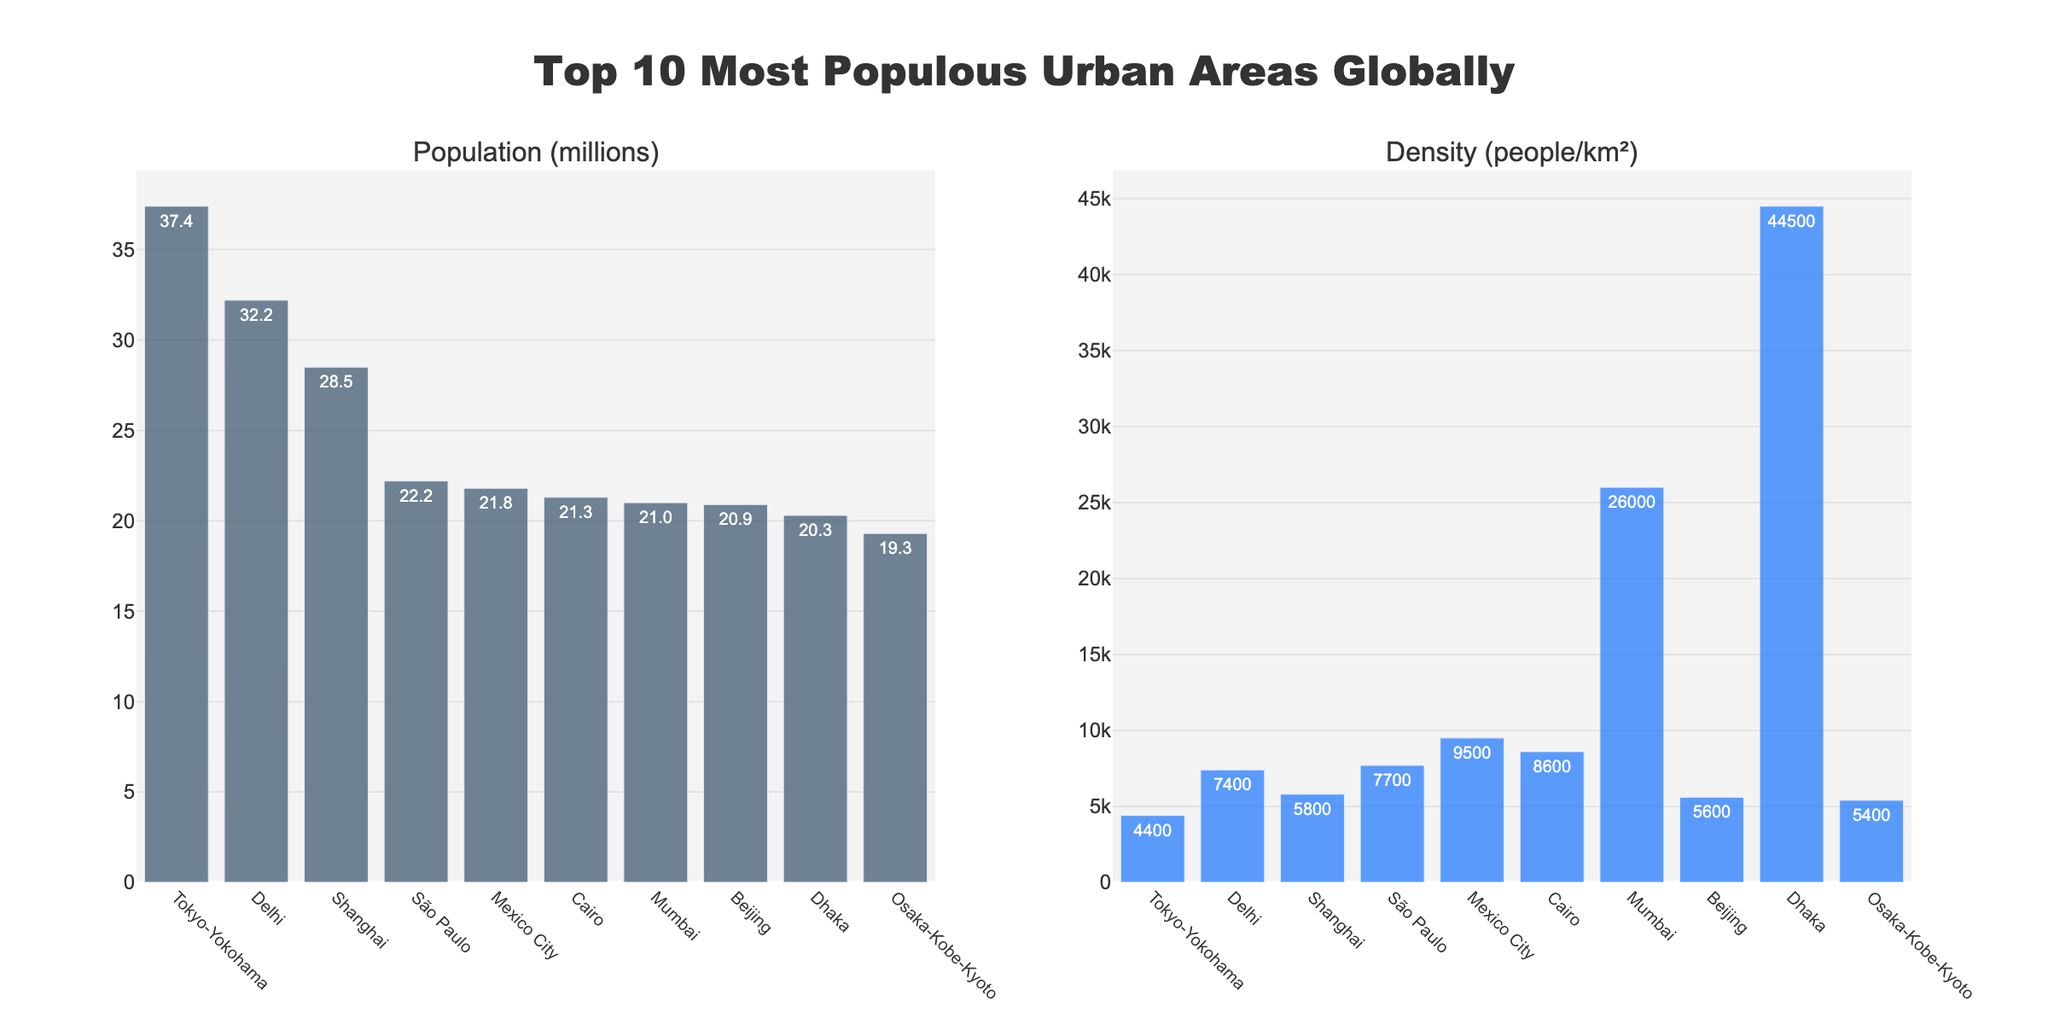Which urban area has the highest population? The bar chart shows the population of each urban area. The tallest bar in the Population (millions) subplot corresponds to Tokyo-Yokohama.
Answer: Tokyo-Yokohama What is the population difference between Shanghai and São Paulo? Find the population values for Shanghai and São Paulo from the Population (millions) subplot (Shanghai: 28.5 million, São Paulo: 22.2 million). Subtract the smaller from the larger. 28.5 - 22.2 = 6.3
Answer: 6.3 million Which urban area has the highest population density? Examine the Density (people/km²) subplot to find the tallest bar, which represents the highest density. The tallest bar is for Dhaka.
Answer: Dhaka What is the combined population of the top 3 most populous urban areas? Identify the top 3 most populous urban areas from the Population (millions) subplot: Tokyo-Yokohama (37.4), Delhi (32.2), and Shanghai (28.5). Add their populations together. 37.4 + 32.2 + 28.5 = 98.1
Answer: 98.1 million Compare the population density between Cairo and Beijing. Which one is denser, and by how much? Find the population density of Cairo (8600) and Beijing (5600) from the Density (people/km²) subplot, then subtract the smaller from the larger to find the difference. 8600 - 5600 = 3000
Answer: Cairo; 3000 people/km² Which urban area has the smallest population among the top 10, and what is its density? Identify the shortest bar in the Population (millions) subplot (Osaka-Kobe-Kyoto: 19.3 million), then find its corresponding density in the Density (people/km²) subplot (5400).
Answer: Osaka-Kobe-Kyoto; 5400 people/km² What is the average population density of the top 5 most populous urban areas? Identify the top 5 most populous urban areas: Tokyo-Yokohama, Delhi, Shanghai, São Paulo, and Mexico City. Find their densities (4400, 7400, 5800, 7700, 9500), sum them, and divide by 5. (4400 + 7400 + 5800 + 7700 + 9500) / 5 = 6960
Answer: 6960 people/km² How does the population of Mumbai compare to that of Dhaka? Get the population values for Mumbai (21.0 million) and Dhaka (20.3 million) from the Population (millions) subplot. Since 21.0 is more than 20.3, Mumbai has a higher population.
Answer: Mumbai is higher What is the population density difference between the densest urban area and the least dense one? The densest urban area is Dhaka (44500 people/km²) and the least dense is Tokyo-Yokohama (4400 people/km²). Subtract the smaller from the larger. 44500 - 4400 = 40100
Answer: 40100 people/km² Which urban area has a higher population density: São Paulo or Mexico City? Compare the densities from the Density (people/km²) subplot: São Paulo (7700) and Mexico City (9500). Since 9500 > 7700, Mexico City has a higher density.
Answer: Mexico City 